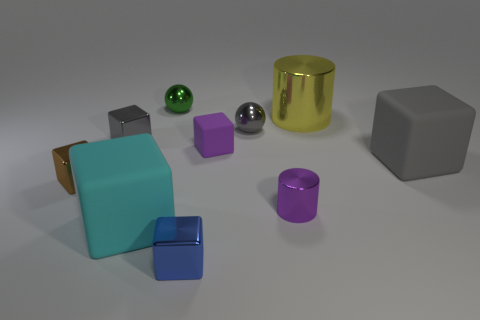There is a small thing that is the same color as the tiny rubber block; what is its material?
Provide a succinct answer. Metal. Are there any small green things right of the purple block?
Provide a succinct answer. No. There is a object that is behind the big gray rubber object and right of the purple metallic thing; what is it made of?
Your response must be concise. Metal. There is another large matte thing that is the same shape as the large gray matte object; what color is it?
Give a very brief answer. Cyan. Are there any tiny green balls that are to the right of the block in front of the cyan rubber thing?
Offer a very short reply. No. How big is the yellow metallic object?
Ensure brevity in your answer.  Large. What shape is the tiny thing that is both on the left side of the small green metal thing and right of the brown metal block?
Ensure brevity in your answer.  Cube. How many yellow things are large blocks or tiny metallic cubes?
Your answer should be compact. 0. Is the size of the gray metal object right of the tiny purple matte block the same as the shiny cylinder in front of the small brown block?
Offer a terse response. Yes. How many objects are large green matte blocks or metallic spheres?
Your answer should be compact. 2. 